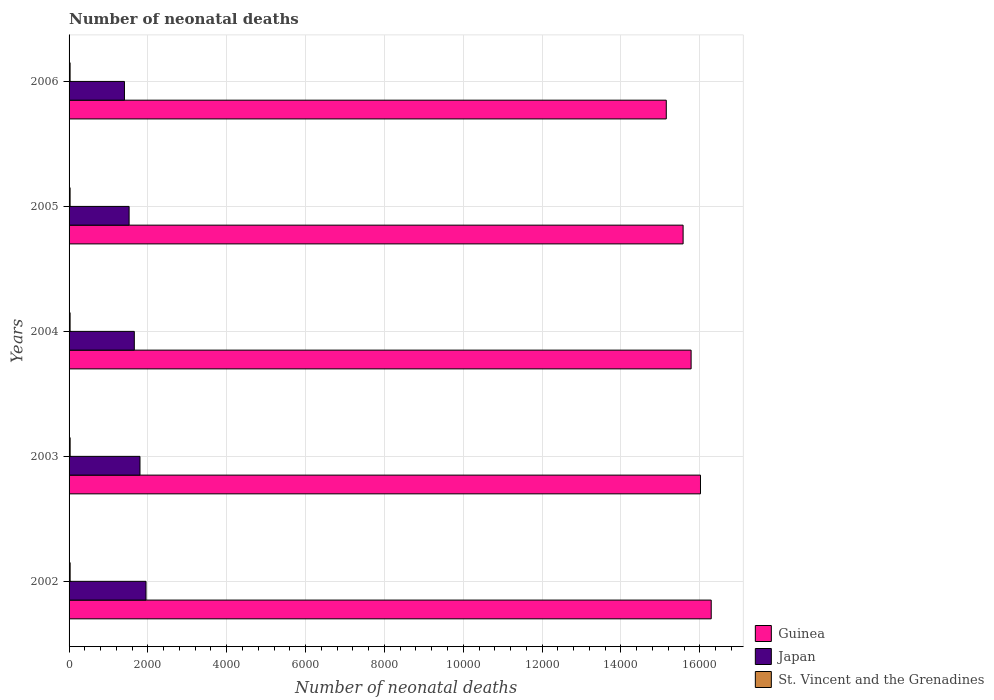How many groups of bars are there?
Offer a very short reply. 5. Are the number of bars per tick equal to the number of legend labels?
Your answer should be compact. Yes. Are the number of bars on each tick of the Y-axis equal?
Provide a short and direct response. Yes. How many bars are there on the 2nd tick from the top?
Your answer should be very brief. 3. In how many cases, is the number of bars for a given year not equal to the number of legend labels?
Make the answer very short. 0. What is the number of neonatal deaths in in St. Vincent and the Grenadines in 2005?
Give a very brief answer. 26. Across all years, what is the maximum number of neonatal deaths in in Japan?
Your response must be concise. 1952. Across all years, what is the minimum number of neonatal deaths in in Japan?
Your answer should be compact. 1405. In which year was the number of neonatal deaths in in Japan minimum?
Make the answer very short. 2006. What is the total number of neonatal deaths in in Guinea in the graph?
Your answer should be very brief. 7.88e+04. What is the difference between the number of neonatal deaths in in Japan in 2004 and that in 2005?
Your answer should be very brief. 132. What is the difference between the number of neonatal deaths in in Japan in 2003 and the number of neonatal deaths in in Guinea in 2002?
Keep it short and to the point. -1.45e+04. What is the average number of neonatal deaths in in St. Vincent and the Grenadines per year?
Provide a succinct answer. 26.4. In the year 2003, what is the difference between the number of neonatal deaths in in Guinea and number of neonatal deaths in in Japan?
Offer a very short reply. 1.42e+04. What is the ratio of the number of neonatal deaths in in Japan in 2003 to that in 2004?
Give a very brief answer. 1.09. Is the number of neonatal deaths in in Japan in 2003 less than that in 2006?
Offer a very short reply. No. What is the difference between the highest and the second highest number of neonatal deaths in in Japan?
Make the answer very short. 153. What is the difference between the highest and the lowest number of neonatal deaths in in St. Vincent and the Grenadines?
Your answer should be compact. 1. In how many years, is the number of neonatal deaths in in Guinea greater than the average number of neonatal deaths in in Guinea taken over all years?
Provide a short and direct response. 3. Is the sum of the number of neonatal deaths in in St. Vincent and the Grenadines in 2002 and 2003 greater than the maximum number of neonatal deaths in in Guinea across all years?
Ensure brevity in your answer.  No. What does the 1st bar from the top in 2002 represents?
Keep it short and to the point. St. Vincent and the Grenadines. What does the 1st bar from the bottom in 2005 represents?
Make the answer very short. Guinea. Are all the bars in the graph horizontal?
Your response must be concise. Yes. How many years are there in the graph?
Ensure brevity in your answer.  5. Does the graph contain grids?
Your response must be concise. Yes. Where does the legend appear in the graph?
Make the answer very short. Bottom right. How are the legend labels stacked?
Offer a terse response. Vertical. What is the title of the graph?
Provide a succinct answer. Number of neonatal deaths. What is the label or title of the X-axis?
Your response must be concise. Number of neonatal deaths. What is the label or title of the Y-axis?
Ensure brevity in your answer.  Years. What is the Number of neonatal deaths of Guinea in 2002?
Provide a succinct answer. 1.63e+04. What is the Number of neonatal deaths in Japan in 2002?
Make the answer very short. 1952. What is the Number of neonatal deaths of St. Vincent and the Grenadines in 2002?
Offer a very short reply. 27. What is the Number of neonatal deaths in Guinea in 2003?
Your answer should be very brief. 1.60e+04. What is the Number of neonatal deaths of Japan in 2003?
Offer a very short reply. 1799. What is the Number of neonatal deaths of Guinea in 2004?
Provide a succinct answer. 1.58e+04. What is the Number of neonatal deaths of Japan in 2004?
Ensure brevity in your answer.  1655. What is the Number of neonatal deaths in Guinea in 2005?
Ensure brevity in your answer.  1.56e+04. What is the Number of neonatal deaths in Japan in 2005?
Your answer should be very brief. 1523. What is the Number of neonatal deaths of St. Vincent and the Grenadines in 2005?
Your answer should be very brief. 26. What is the Number of neonatal deaths of Guinea in 2006?
Offer a terse response. 1.52e+04. What is the Number of neonatal deaths in Japan in 2006?
Ensure brevity in your answer.  1405. Across all years, what is the maximum Number of neonatal deaths of Guinea?
Keep it short and to the point. 1.63e+04. Across all years, what is the maximum Number of neonatal deaths of Japan?
Your response must be concise. 1952. Across all years, what is the minimum Number of neonatal deaths of Guinea?
Give a very brief answer. 1.52e+04. Across all years, what is the minimum Number of neonatal deaths in Japan?
Offer a terse response. 1405. What is the total Number of neonatal deaths of Guinea in the graph?
Give a very brief answer. 7.88e+04. What is the total Number of neonatal deaths of Japan in the graph?
Ensure brevity in your answer.  8334. What is the total Number of neonatal deaths of St. Vincent and the Grenadines in the graph?
Your response must be concise. 132. What is the difference between the Number of neonatal deaths in Guinea in 2002 and that in 2003?
Your answer should be compact. 272. What is the difference between the Number of neonatal deaths of Japan in 2002 and that in 2003?
Keep it short and to the point. 153. What is the difference between the Number of neonatal deaths in Guinea in 2002 and that in 2004?
Keep it short and to the point. 510. What is the difference between the Number of neonatal deaths of Japan in 2002 and that in 2004?
Offer a very short reply. 297. What is the difference between the Number of neonatal deaths of St. Vincent and the Grenadines in 2002 and that in 2004?
Offer a terse response. 1. What is the difference between the Number of neonatal deaths of Guinea in 2002 and that in 2005?
Your answer should be very brief. 713. What is the difference between the Number of neonatal deaths of Japan in 2002 and that in 2005?
Ensure brevity in your answer.  429. What is the difference between the Number of neonatal deaths of St. Vincent and the Grenadines in 2002 and that in 2005?
Offer a terse response. 1. What is the difference between the Number of neonatal deaths in Guinea in 2002 and that in 2006?
Your response must be concise. 1140. What is the difference between the Number of neonatal deaths of Japan in 2002 and that in 2006?
Your response must be concise. 547. What is the difference between the Number of neonatal deaths of Guinea in 2003 and that in 2004?
Provide a succinct answer. 238. What is the difference between the Number of neonatal deaths in Japan in 2003 and that in 2004?
Give a very brief answer. 144. What is the difference between the Number of neonatal deaths in Guinea in 2003 and that in 2005?
Keep it short and to the point. 441. What is the difference between the Number of neonatal deaths in Japan in 2003 and that in 2005?
Your answer should be compact. 276. What is the difference between the Number of neonatal deaths of Guinea in 2003 and that in 2006?
Offer a very short reply. 868. What is the difference between the Number of neonatal deaths of Japan in 2003 and that in 2006?
Give a very brief answer. 394. What is the difference between the Number of neonatal deaths of St. Vincent and the Grenadines in 2003 and that in 2006?
Offer a very short reply. 1. What is the difference between the Number of neonatal deaths in Guinea in 2004 and that in 2005?
Provide a succinct answer. 203. What is the difference between the Number of neonatal deaths of Japan in 2004 and that in 2005?
Your answer should be very brief. 132. What is the difference between the Number of neonatal deaths of Guinea in 2004 and that in 2006?
Offer a terse response. 630. What is the difference between the Number of neonatal deaths in Japan in 2004 and that in 2006?
Your answer should be compact. 250. What is the difference between the Number of neonatal deaths in St. Vincent and the Grenadines in 2004 and that in 2006?
Provide a succinct answer. 0. What is the difference between the Number of neonatal deaths in Guinea in 2005 and that in 2006?
Your answer should be compact. 427. What is the difference between the Number of neonatal deaths of Japan in 2005 and that in 2006?
Offer a terse response. 118. What is the difference between the Number of neonatal deaths in Guinea in 2002 and the Number of neonatal deaths in Japan in 2003?
Your response must be concise. 1.45e+04. What is the difference between the Number of neonatal deaths of Guinea in 2002 and the Number of neonatal deaths of St. Vincent and the Grenadines in 2003?
Offer a terse response. 1.63e+04. What is the difference between the Number of neonatal deaths in Japan in 2002 and the Number of neonatal deaths in St. Vincent and the Grenadines in 2003?
Offer a very short reply. 1925. What is the difference between the Number of neonatal deaths in Guinea in 2002 and the Number of neonatal deaths in Japan in 2004?
Make the answer very short. 1.46e+04. What is the difference between the Number of neonatal deaths in Guinea in 2002 and the Number of neonatal deaths in St. Vincent and the Grenadines in 2004?
Your answer should be compact. 1.63e+04. What is the difference between the Number of neonatal deaths of Japan in 2002 and the Number of neonatal deaths of St. Vincent and the Grenadines in 2004?
Offer a very short reply. 1926. What is the difference between the Number of neonatal deaths of Guinea in 2002 and the Number of neonatal deaths of Japan in 2005?
Your answer should be very brief. 1.48e+04. What is the difference between the Number of neonatal deaths in Guinea in 2002 and the Number of neonatal deaths in St. Vincent and the Grenadines in 2005?
Ensure brevity in your answer.  1.63e+04. What is the difference between the Number of neonatal deaths of Japan in 2002 and the Number of neonatal deaths of St. Vincent and the Grenadines in 2005?
Keep it short and to the point. 1926. What is the difference between the Number of neonatal deaths of Guinea in 2002 and the Number of neonatal deaths of Japan in 2006?
Provide a short and direct response. 1.49e+04. What is the difference between the Number of neonatal deaths in Guinea in 2002 and the Number of neonatal deaths in St. Vincent and the Grenadines in 2006?
Make the answer very short. 1.63e+04. What is the difference between the Number of neonatal deaths in Japan in 2002 and the Number of neonatal deaths in St. Vincent and the Grenadines in 2006?
Keep it short and to the point. 1926. What is the difference between the Number of neonatal deaths in Guinea in 2003 and the Number of neonatal deaths in Japan in 2004?
Make the answer very short. 1.44e+04. What is the difference between the Number of neonatal deaths in Guinea in 2003 and the Number of neonatal deaths in St. Vincent and the Grenadines in 2004?
Offer a terse response. 1.60e+04. What is the difference between the Number of neonatal deaths of Japan in 2003 and the Number of neonatal deaths of St. Vincent and the Grenadines in 2004?
Offer a terse response. 1773. What is the difference between the Number of neonatal deaths of Guinea in 2003 and the Number of neonatal deaths of Japan in 2005?
Offer a very short reply. 1.45e+04. What is the difference between the Number of neonatal deaths in Guinea in 2003 and the Number of neonatal deaths in St. Vincent and the Grenadines in 2005?
Your response must be concise. 1.60e+04. What is the difference between the Number of neonatal deaths in Japan in 2003 and the Number of neonatal deaths in St. Vincent and the Grenadines in 2005?
Make the answer very short. 1773. What is the difference between the Number of neonatal deaths of Guinea in 2003 and the Number of neonatal deaths of Japan in 2006?
Make the answer very short. 1.46e+04. What is the difference between the Number of neonatal deaths of Guinea in 2003 and the Number of neonatal deaths of St. Vincent and the Grenadines in 2006?
Provide a short and direct response. 1.60e+04. What is the difference between the Number of neonatal deaths in Japan in 2003 and the Number of neonatal deaths in St. Vincent and the Grenadines in 2006?
Your answer should be very brief. 1773. What is the difference between the Number of neonatal deaths in Guinea in 2004 and the Number of neonatal deaths in Japan in 2005?
Provide a succinct answer. 1.43e+04. What is the difference between the Number of neonatal deaths of Guinea in 2004 and the Number of neonatal deaths of St. Vincent and the Grenadines in 2005?
Your response must be concise. 1.58e+04. What is the difference between the Number of neonatal deaths in Japan in 2004 and the Number of neonatal deaths in St. Vincent and the Grenadines in 2005?
Give a very brief answer. 1629. What is the difference between the Number of neonatal deaths of Guinea in 2004 and the Number of neonatal deaths of Japan in 2006?
Make the answer very short. 1.44e+04. What is the difference between the Number of neonatal deaths of Guinea in 2004 and the Number of neonatal deaths of St. Vincent and the Grenadines in 2006?
Give a very brief answer. 1.58e+04. What is the difference between the Number of neonatal deaths in Japan in 2004 and the Number of neonatal deaths in St. Vincent and the Grenadines in 2006?
Your answer should be compact. 1629. What is the difference between the Number of neonatal deaths of Guinea in 2005 and the Number of neonatal deaths of Japan in 2006?
Your response must be concise. 1.42e+04. What is the difference between the Number of neonatal deaths of Guinea in 2005 and the Number of neonatal deaths of St. Vincent and the Grenadines in 2006?
Your answer should be compact. 1.56e+04. What is the difference between the Number of neonatal deaths of Japan in 2005 and the Number of neonatal deaths of St. Vincent and the Grenadines in 2006?
Offer a very short reply. 1497. What is the average Number of neonatal deaths in Guinea per year?
Your answer should be compact. 1.58e+04. What is the average Number of neonatal deaths in Japan per year?
Keep it short and to the point. 1666.8. What is the average Number of neonatal deaths of St. Vincent and the Grenadines per year?
Your answer should be compact. 26.4. In the year 2002, what is the difference between the Number of neonatal deaths of Guinea and Number of neonatal deaths of Japan?
Give a very brief answer. 1.43e+04. In the year 2002, what is the difference between the Number of neonatal deaths of Guinea and Number of neonatal deaths of St. Vincent and the Grenadines?
Make the answer very short. 1.63e+04. In the year 2002, what is the difference between the Number of neonatal deaths of Japan and Number of neonatal deaths of St. Vincent and the Grenadines?
Your response must be concise. 1925. In the year 2003, what is the difference between the Number of neonatal deaths in Guinea and Number of neonatal deaths in Japan?
Offer a very short reply. 1.42e+04. In the year 2003, what is the difference between the Number of neonatal deaths in Guinea and Number of neonatal deaths in St. Vincent and the Grenadines?
Make the answer very short. 1.60e+04. In the year 2003, what is the difference between the Number of neonatal deaths of Japan and Number of neonatal deaths of St. Vincent and the Grenadines?
Offer a very short reply. 1772. In the year 2004, what is the difference between the Number of neonatal deaths of Guinea and Number of neonatal deaths of Japan?
Your answer should be compact. 1.41e+04. In the year 2004, what is the difference between the Number of neonatal deaths in Guinea and Number of neonatal deaths in St. Vincent and the Grenadines?
Your response must be concise. 1.58e+04. In the year 2004, what is the difference between the Number of neonatal deaths of Japan and Number of neonatal deaths of St. Vincent and the Grenadines?
Provide a succinct answer. 1629. In the year 2005, what is the difference between the Number of neonatal deaths of Guinea and Number of neonatal deaths of Japan?
Offer a very short reply. 1.41e+04. In the year 2005, what is the difference between the Number of neonatal deaths in Guinea and Number of neonatal deaths in St. Vincent and the Grenadines?
Give a very brief answer. 1.56e+04. In the year 2005, what is the difference between the Number of neonatal deaths in Japan and Number of neonatal deaths in St. Vincent and the Grenadines?
Offer a very short reply. 1497. In the year 2006, what is the difference between the Number of neonatal deaths in Guinea and Number of neonatal deaths in Japan?
Your answer should be compact. 1.37e+04. In the year 2006, what is the difference between the Number of neonatal deaths of Guinea and Number of neonatal deaths of St. Vincent and the Grenadines?
Your answer should be very brief. 1.51e+04. In the year 2006, what is the difference between the Number of neonatal deaths of Japan and Number of neonatal deaths of St. Vincent and the Grenadines?
Ensure brevity in your answer.  1379. What is the ratio of the Number of neonatal deaths of Guinea in 2002 to that in 2003?
Keep it short and to the point. 1.02. What is the ratio of the Number of neonatal deaths of Japan in 2002 to that in 2003?
Offer a terse response. 1.08. What is the ratio of the Number of neonatal deaths of St. Vincent and the Grenadines in 2002 to that in 2003?
Provide a short and direct response. 1. What is the ratio of the Number of neonatal deaths of Guinea in 2002 to that in 2004?
Make the answer very short. 1.03. What is the ratio of the Number of neonatal deaths of Japan in 2002 to that in 2004?
Your answer should be compact. 1.18. What is the ratio of the Number of neonatal deaths of Guinea in 2002 to that in 2005?
Make the answer very short. 1.05. What is the ratio of the Number of neonatal deaths in Japan in 2002 to that in 2005?
Give a very brief answer. 1.28. What is the ratio of the Number of neonatal deaths in St. Vincent and the Grenadines in 2002 to that in 2005?
Make the answer very short. 1.04. What is the ratio of the Number of neonatal deaths in Guinea in 2002 to that in 2006?
Give a very brief answer. 1.08. What is the ratio of the Number of neonatal deaths of Japan in 2002 to that in 2006?
Your response must be concise. 1.39. What is the ratio of the Number of neonatal deaths in Guinea in 2003 to that in 2004?
Your answer should be very brief. 1.02. What is the ratio of the Number of neonatal deaths of Japan in 2003 to that in 2004?
Ensure brevity in your answer.  1.09. What is the ratio of the Number of neonatal deaths in St. Vincent and the Grenadines in 2003 to that in 2004?
Your response must be concise. 1.04. What is the ratio of the Number of neonatal deaths of Guinea in 2003 to that in 2005?
Make the answer very short. 1.03. What is the ratio of the Number of neonatal deaths in Japan in 2003 to that in 2005?
Provide a succinct answer. 1.18. What is the ratio of the Number of neonatal deaths of St. Vincent and the Grenadines in 2003 to that in 2005?
Make the answer very short. 1.04. What is the ratio of the Number of neonatal deaths in Guinea in 2003 to that in 2006?
Your answer should be very brief. 1.06. What is the ratio of the Number of neonatal deaths of Japan in 2003 to that in 2006?
Give a very brief answer. 1.28. What is the ratio of the Number of neonatal deaths in Japan in 2004 to that in 2005?
Keep it short and to the point. 1.09. What is the ratio of the Number of neonatal deaths in St. Vincent and the Grenadines in 2004 to that in 2005?
Make the answer very short. 1. What is the ratio of the Number of neonatal deaths in Guinea in 2004 to that in 2006?
Ensure brevity in your answer.  1.04. What is the ratio of the Number of neonatal deaths in Japan in 2004 to that in 2006?
Give a very brief answer. 1.18. What is the ratio of the Number of neonatal deaths of Guinea in 2005 to that in 2006?
Your answer should be compact. 1.03. What is the ratio of the Number of neonatal deaths of Japan in 2005 to that in 2006?
Your answer should be very brief. 1.08. What is the difference between the highest and the second highest Number of neonatal deaths of Guinea?
Offer a terse response. 272. What is the difference between the highest and the second highest Number of neonatal deaths in Japan?
Offer a very short reply. 153. What is the difference between the highest and the lowest Number of neonatal deaths of Guinea?
Keep it short and to the point. 1140. What is the difference between the highest and the lowest Number of neonatal deaths in Japan?
Your response must be concise. 547. 